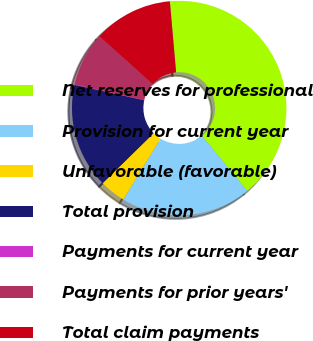Convert chart. <chart><loc_0><loc_0><loc_500><loc_500><pie_chart><fcel>Net reserves for professional<fcel>Provision for current year<fcel>Unfavorable (favorable)<fcel>Total provision<fcel>Payments for current year<fcel>Payments for prior years'<fcel>Total claim payments<nl><fcel>40.45%<fcel>19.67%<fcel>3.92%<fcel>15.82%<fcel>0.07%<fcel>8.1%<fcel>11.96%<nl></chart> 